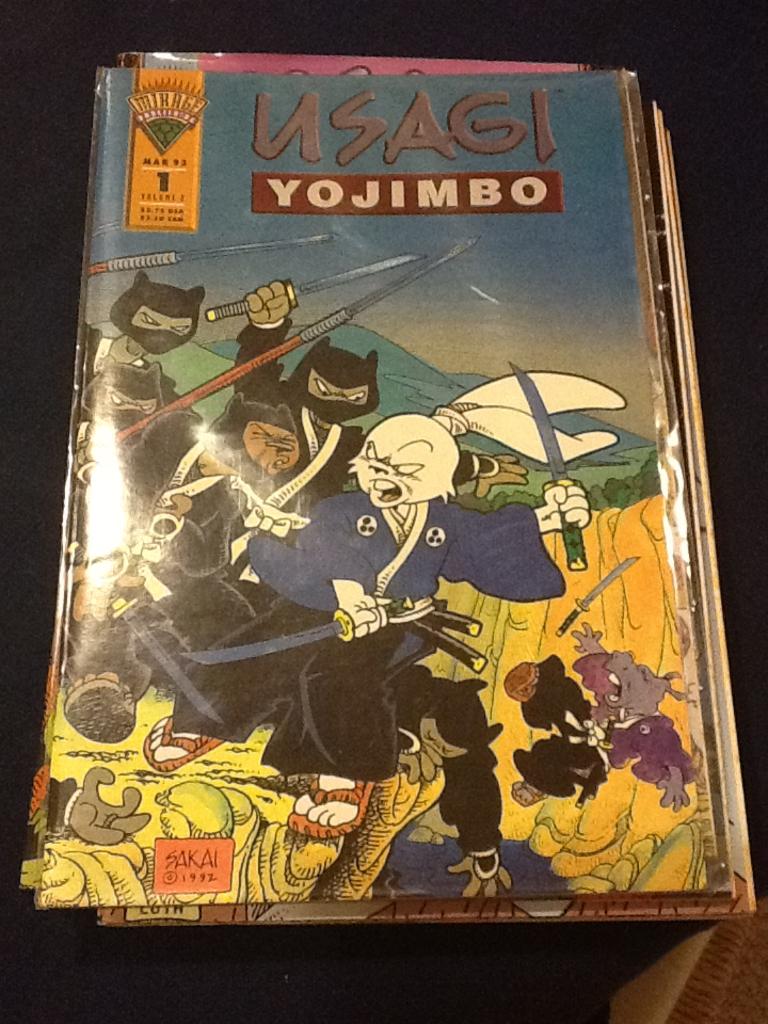What is the comic?
Your answer should be very brief. Usagi yojimbo. 